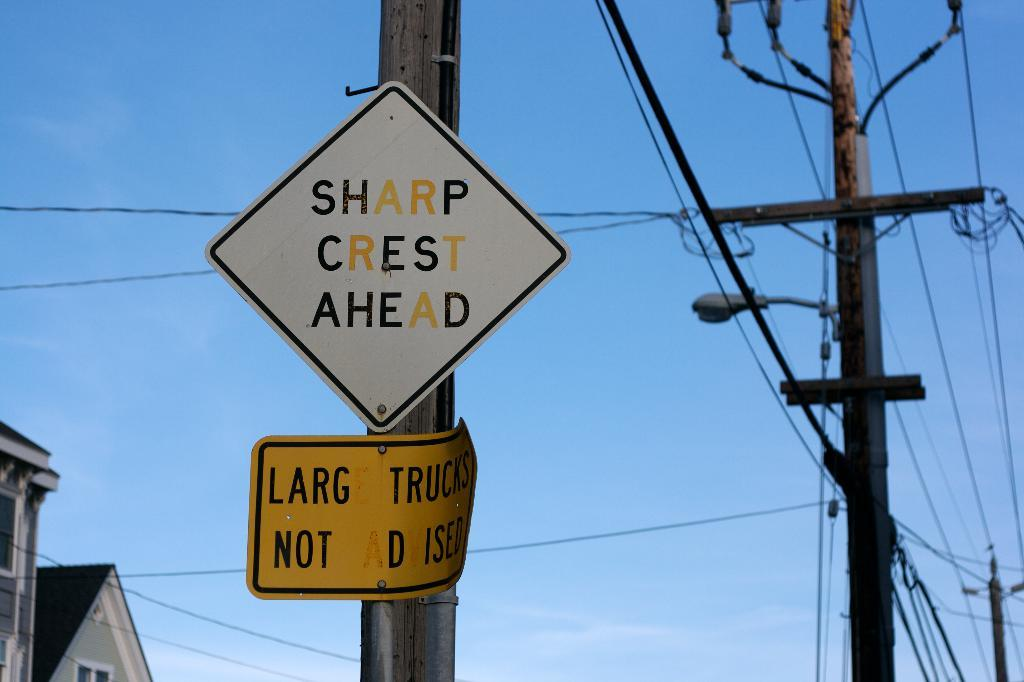<image>
Write a terse but informative summary of the picture. a sign for Sharp Crest Ahead on a pole in the road 